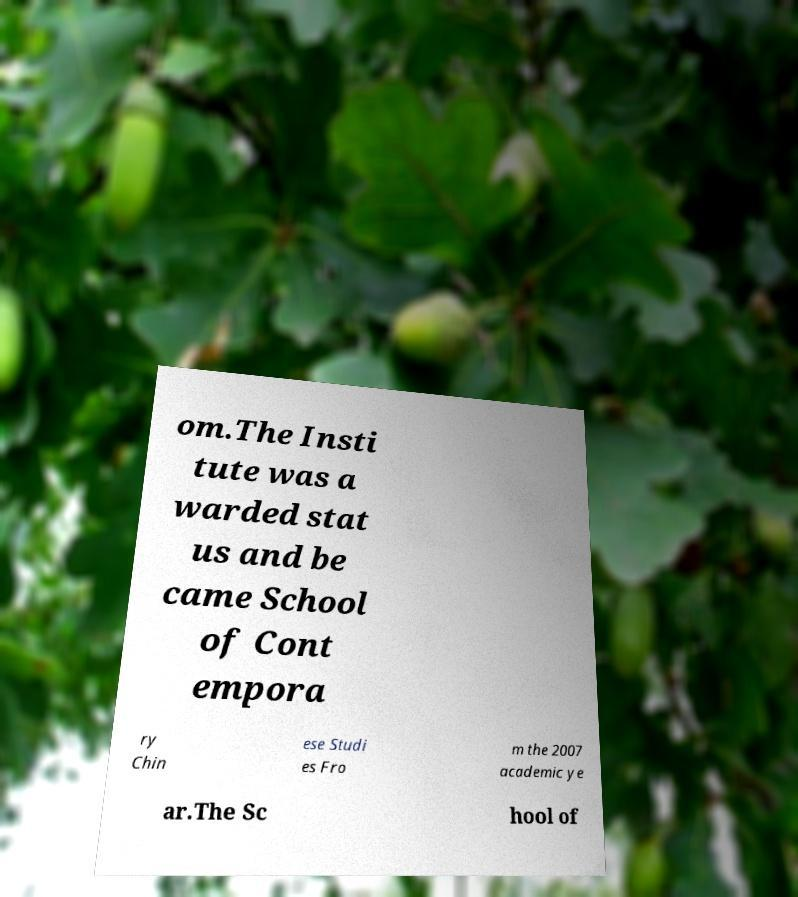Could you extract and type out the text from this image? om.The Insti tute was a warded stat us and be came School of Cont empora ry Chin ese Studi es Fro m the 2007 academic ye ar.The Sc hool of 